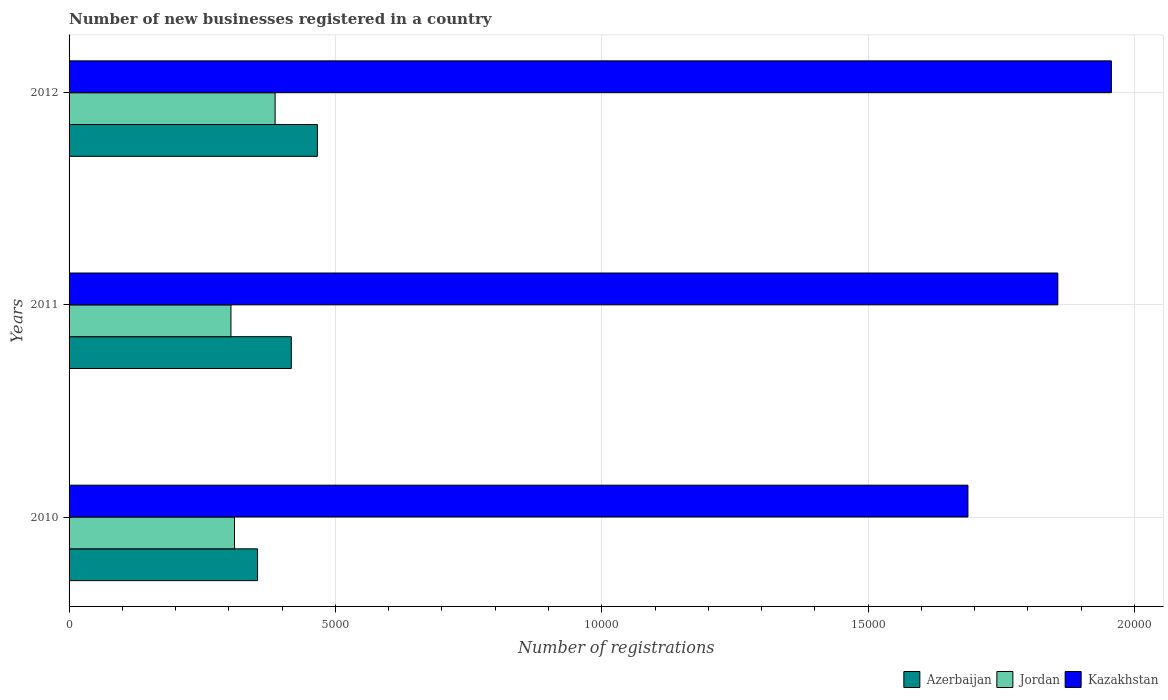Are the number of bars per tick equal to the number of legend labels?
Your answer should be very brief. Yes. Are the number of bars on each tick of the Y-axis equal?
Provide a short and direct response. Yes. How many bars are there on the 1st tick from the top?
Make the answer very short. 3. What is the number of new businesses registered in Kazakhstan in 2012?
Provide a succinct answer. 1.96e+04. Across all years, what is the maximum number of new businesses registered in Jordan?
Keep it short and to the point. 3868. Across all years, what is the minimum number of new businesses registered in Jordan?
Your answer should be very brief. 3039. What is the total number of new businesses registered in Kazakhstan in the graph?
Offer a terse response. 5.50e+04. What is the difference between the number of new businesses registered in Azerbaijan in 2010 and that in 2011?
Your answer should be compact. -633. What is the difference between the number of new businesses registered in Jordan in 2010 and the number of new businesses registered in Azerbaijan in 2012?
Make the answer very short. -1556. What is the average number of new businesses registered in Jordan per year?
Make the answer very short. 3337.67. In the year 2012, what is the difference between the number of new businesses registered in Kazakhstan and number of new businesses registered in Jordan?
Give a very brief answer. 1.57e+04. What is the ratio of the number of new businesses registered in Jordan in 2010 to that in 2012?
Your response must be concise. 0.8. Is the number of new businesses registered in Kazakhstan in 2011 less than that in 2012?
Ensure brevity in your answer.  Yes. What is the difference between the highest and the second highest number of new businesses registered in Azerbaijan?
Provide a succinct answer. 490. What is the difference between the highest and the lowest number of new businesses registered in Jordan?
Provide a short and direct response. 829. Is the sum of the number of new businesses registered in Jordan in 2011 and 2012 greater than the maximum number of new businesses registered in Kazakhstan across all years?
Your answer should be compact. No. What does the 3rd bar from the top in 2011 represents?
Provide a succinct answer. Azerbaijan. What does the 3rd bar from the bottom in 2011 represents?
Offer a very short reply. Kazakhstan. Is it the case that in every year, the sum of the number of new businesses registered in Azerbaijan and number of new businesses registered in Kazakhstan is greater than the number of new businesses registered in Jordan?
Provide a succinct answer. Yes. Are all the bars in the graph horizontal?
Give a very brief answer. Yes. Are the values on the major ticks of X-axis written in scientific E-notation?
Provide a succinct answer. No. Does the graph contain any zero values?
Your answer should be very brief. No. Does the graph contain grids?
Keep it short and to the point. Yes. Where does the legend appear in the graph?
Keep it short and to the point. Bottom right. How are the legend labels stacked?
Keep it short and to the point. Horizontal. What is the title of the graph?
Give a very brief answer. Number of new businesses registered in a country. Does "Sierra Leone" appear as one of the legend labels in the graph?
Your response must be concise. No. What is the label or title of the X-axis?
Ensure brevity in your answer.  Number of registrations. What is the label or title of the Y-axis?
Your answer should be compact. Years. What is the Number of registrations in Azerbaijan in 2010?
Your answer should be compact. 3539. What is the Number of registrations in Jordan in 2010?
Make the answer very short. 3106. What is the Number of registrations of Kazakhstan in 2010?
Provide a succinct answer. 1.69e+04. What is the Number of registrations of Azerbaijan in 2011?
Provide a short and direct response. 4172. What is the Number of registrations in Jordan in 2011?
Offer a terse response. 3039. What is the Number of registrations of Kazakhstan in 2011?
Your response must be concise. 1.86e+04. What is the Number of registrations in Azerbaijan in 2012?
Keep it short and to the point. 4662. What is the Number of registrations in Jordan in 2012?
Your answer should be compact. 3868. What is the Number of registrations of Kazakhstan in 2012?
Give a very brief answer. 1.96e+04. Across all years, what is the maximum Number of registrations of Azerbaijan?
Make the answer very short. 4662. Across all years, what is the maximum Number of registrations of Jordan?
Your response must be concise. 3868. Across all years, what is the maximum Number of registrations in Kazakhstan?
Offer a very short reply. 1.96e+04. Across all years, what is the minimum Number of registrations of Azerbaijan?
Offer a very short reply. 3539. Across all years, what is the minimum Number of registrations of Jordan?
Make the answer very short. 3039. Across all years, what is the minimum Number of registrations in Kazakhstan?
Offer a very short reply. 1.69e+04. What is the total Number of registrations in Azerbaijan in the graph?
Make the answer very short. 1.24e+04. What is the total Number of registrations in Jordan in the graph?
Give a very brief answer. 1.00e+04. What is the total Number of registrations in Kazakhstan in the graph?
Ensure brevity in your answer.  5.50e+04. What is the difference between the Number of registrations in Azerbaijan in 2010 and that in 2011?
Make the answer very short. -633. What is the difference between the Number of registrations of Jordan in 2010 and that in 2011?
Provide a succinct answer. 67. What is the difference between the Number of registrations of Kazakhstan in 2010 and that in 2011?
Keep it short and to the point. -1688. What is the difference between the Number of registrations of Azerbaijan in 2010 and that in 2012?
Ensure brevity in your answer.  -1123. What is the difference between the Number of registrations in Jordan in 2010 and that in 2012?
Provide a short and direct response. -762. What is the difference between the Number of registrations in Kazakhstan in 2010 and that in 2012?
Keep it short and to the point. -2693. What is the difference between the Number of registrations of Azerbaijan in 2011 and that in 2012?
Ensure brevity in your answer.  -490. What is the difference between the Number of registrations of Jordan in 2011 and that in 2012?
Offer a very short reply. -829. What is the difference between the Number of registrations of Kazakhstan in 2011 and that in 2012?
Provide a succinct answer. -1005. What is the difference between the Number of registrations in Azerbaijan in 2010 and the Number of registrations in Kazakhstan in 2011?
Your response must be concise. -1.50e+04. What is the difference between the Number of registrations in Jordan in 2010 and the Number of registrations in Kazakhstan in 2011?
Your answer should be very brief. -1.55e+04. What is the difference between the Number of registrations in Azerbaijan in 2010 and the Number of registrations in Jordan in 2012?
Provide a succinct answer. -329. What is the difference between the Number of registrations of Azerbaijan in 2010 and the Number of registrations of Kazakhstan in 2012?
Offer a terse response. -1.60e+04. What is the difference between the Number of registrations of Jordan in 2010 and the Number of registrations of Kazakhstan in 2012?
Provide a short and direct response. -1.65e+04. What is the difference between the Number of registrations in Azerbaijan in 2011 and the Number of registrations in Jordan in 2012?
Your answer should be very brief. 304. What is the difference between the Number of registrations of Azerbaijan in 2011 and the Number of registrations of Kazakhstan in 2012?
Your answer should be compact. -1.54e+04. What is the difference between the Number of registrations of Jordan in 2011 and the Number of registrations of Kazakhstan in 2012?
Give a very brief answer. -1.65e+04. What is the average Number of registrations of Azerbaijan per year?
Make the answer very short. 4124.33. What is the average Number of registrations in Jordan per year?
Make the answer very short. 3337.67. What is the average Number of registrations in Kazakhstan per year?
Offer a very short reply. 1.83e+04. In the year 2010, what is the difference between the Number of registrations in Azerbaijan and Number of registrations in Jordan?
Offer a very short reply. 433. In the year 2010, what is the difference between the Number of registrations of Azerbaijan and Number of registrations of Kazakhstan?
Offer a terse response. -1.33e+04. In the year 2010, what is the difference between the Number of registrations in Jordan and Number of registrations in Kazakhstan?
Your answer should be very brief. -1.38e+04. In the year 2011, what is the difference between the Number of registrations of Azerbaijan and Number of registrations of Jordan?
Give a very brief answer. 1133. In the year 2011, what is the difference between the Number of registrations in Azerbaijan and Number of registrations in Kazakhstan?
Your response must be concise. -1.44e+04. In the year 2011, what is the difference between the Number of registrations in Jordan and Number of registrations in Kazakhstan?
Provide a short and direct response. -1.55e+04. In the year 2012, what is the difference between the Number of registrations of Azerbaijan and Number of registrations of Jordan?
Provide a succinct answer. 794. In the year 2012, what is the difference between the Number of registrations of Azerbaijan and Number of registrations of Kazakhstan?
Offer a very short reply. -1.49e+04. In the year 2012, what is the difference between the Number of registrations of Jordan and Number of registrations of Kazakhstan?
Give a very brief answer. -1.57e+04. What is the ratio of the Number of registrations of Azerbaijan in 2010 to that in 2011?
Provide a short and direct response. 0.85. What is the ratio of the Number of registrations of Kazakhstan in 2010 to that in 2011?
Ensure brevity in your answer.  0.91. What is the ratio of the Number of registrations in Azerbaijan in 2010 to that in 2012?
Provide a succinct answer. 0.76. What is the ratio of the Number of registrations of Jordan in 2010 to that in 2012?
Keep it short and to the point. 0.8. What is the ratio of the Number of registrations in Kazakhstan in 2010 to that in 2012?
Offer a very short reply. 0.86. What is the ratio of the Number of registrations of Azerbaijan in 2011 to that in 2012?
Make the answer very short. 0.89. What is the ratio of the Number of registrations in Jordan in 2011 to that in 2012?
Make the answer very short. 0.79. What is the ratio of the Number of registrations in Kazakhstan in 2011 to that in 2012?
Your response must be concise. 0.95. What is the difference between the highest and the second highest Number of registrations of Azerbaijan?
Offer a terse response. 490. What is the difference between the highest and the second highest Number of registrations in Jordan?
Ensure brevity in your answer.  762. What is the difference between the highest and the second highest Number of registrations of Kazakhstan?
Provide a succinct answer. 1005. What is the difference between the highest and the lowest Number of registrations in Azerbaijan?
Your answer should be compact. 1123. What is the difference between the highest and the lowest Number of registrations in Jordan?
Your answer should be very brief. 829. What is the difference between the highest and the lowest Number of registrations in Kazakhstan?
Your response must be concise. 2693. 